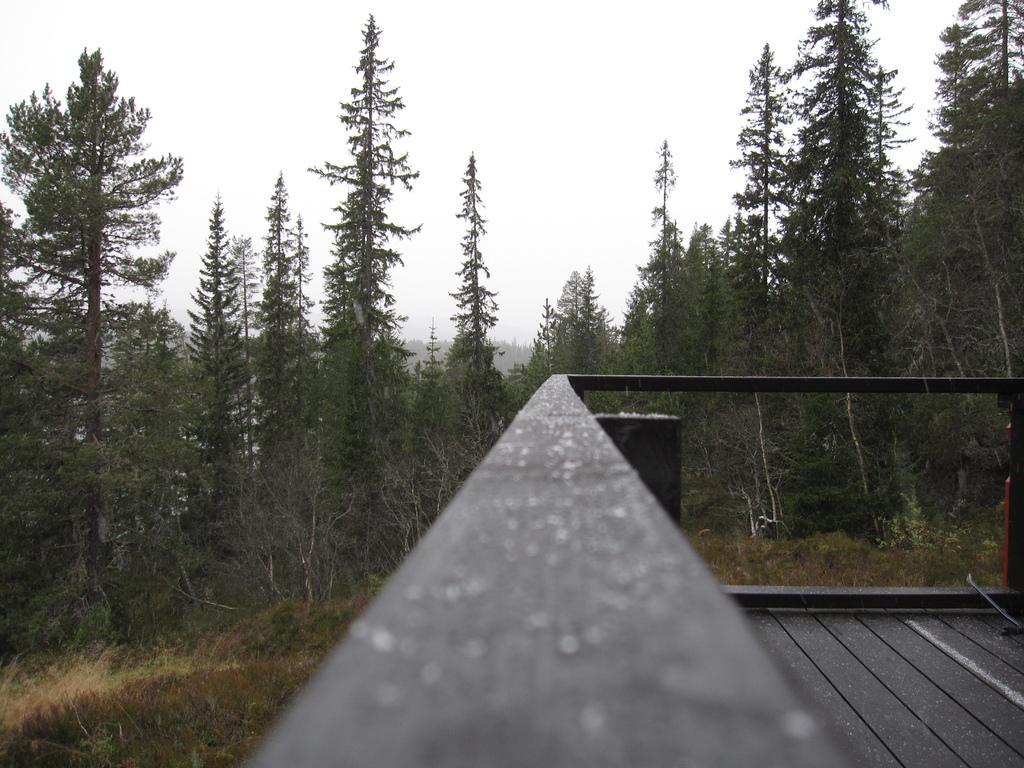Please provide a concise description of this image. In the image there is a balcony on the right side and in the back there are trees all over the land and above its sky. 